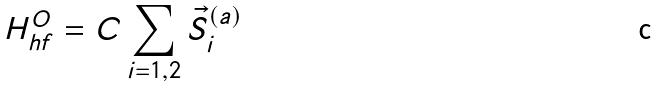Convert formula to latex. <formula><loc_0><loc_0><loc_500><loc_500>H _ { h f } ^ { O } = C \sum _ { i = 1 , 2 } \vec { S } _ { i } ^ { ( a ) }</formula> 